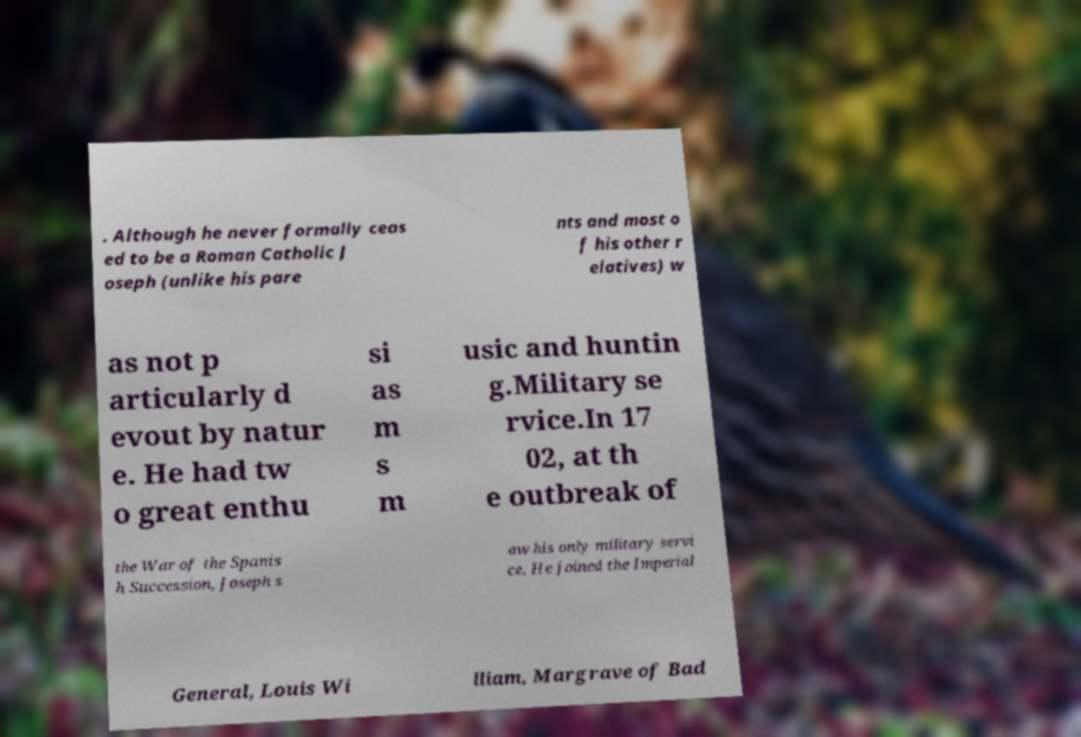Could you extract and type out the text from this image? . Although he never formally ceas ed to be a Roman Catholic J oseph (unlike his pare nts and most o f his other r elatives) w as not p articularly d evout by natur e. He had tw o great enthu si as m s m usic and huntin g.Military se rvice.In 17 02, at th e outbreak of the War of the Spanis h Succession, Joseph s aw his only military servi ce. He joined the Imperial General, Louis Wi lliam, Margrave of Bad 